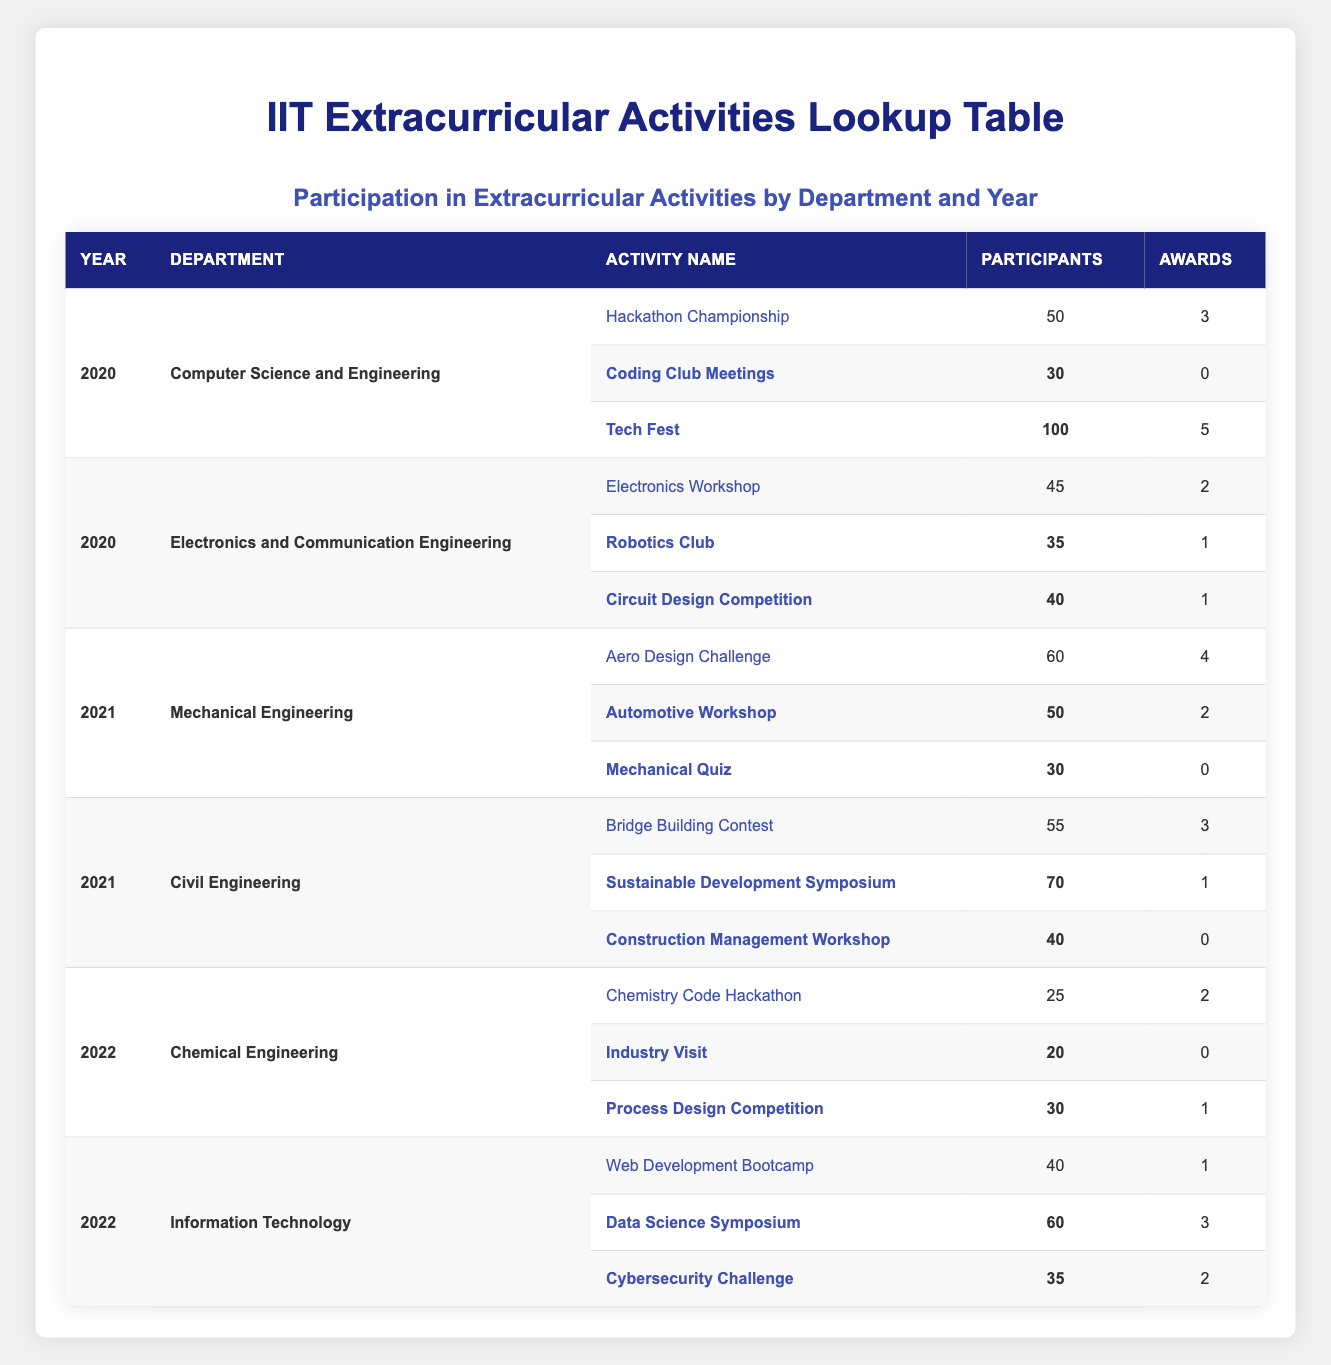What was the total number of participants from the Computer Science and Engineering department in 2020? In 2020, the activities from the Computer Science and Engineering department were: Hackathon Championship (50 participants), Coding Club Meetings (30 participants), and Tech Fest (100 participants). Summing these numbers gives: 50 + 30 + 100 = 180.
Answer: 180 Which activity in 2021 had the highest number of participants in the Mechanical Engineering department? The activities from the Mechanical Engineering department in 2021 were: Aero Design Challenge (60 participants), Automotive Workshop (50 participants), and Mechanical Quiz (30 participants). The highest among these is 60 participants from the Aero Design Challenge.
Answer: Aero Design Challenge Did the Electronics and Communication Engineering department win any awards in 2020? The activities in the Electronics and Communication Engineering department for 2020 had the following awards: Electronics Workshop (2 awards), Robotics Club (1 award), and Circuit Design Competition (1 award). Since there are awards given, the answer is yes.
Answer: Yes Which department had the most participants in extracurricular activities in 2022? For 2022, the Chemical Engineering department had 25 + 20 + 30 = 75 participants, while the Information Technology department had 40 + 60 + 35 = 135 participants. Comparing these sums shows that the Information Technology department had more participants.
Answer: Information Technology On average, how many awards did activities from the Civil Engineering department receive in 2021? The Civil Engineering department's activities in 2021 had: Bridge Building Contest (3 awards), Sustainable Development Symposium (1 award), and Construction Management Workshop (0 awards). The total awards are 3 + 1 + 0 = 4. With 3 activities, the average is 4/3, which is approximately 1.33 (rounded).
Answer: 1.33 